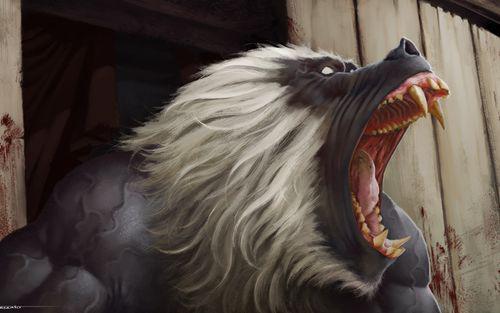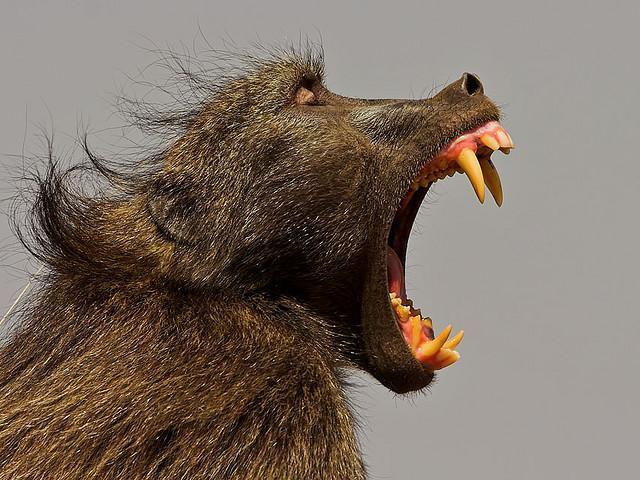The first image is the image on the left, the second image is the image on the right. For the images shown, is this caption "Each image contains the face of an ape with teeth showing, and at least one image shows a wide-open mouth." true? Answer yes or no. Yes. The first image is the image on the left, the second image is the image on the right. Given the left and right images, does the statement "The primate in the image on the left has its mouth wide open." hold true? Answer yes or no. Yes. 